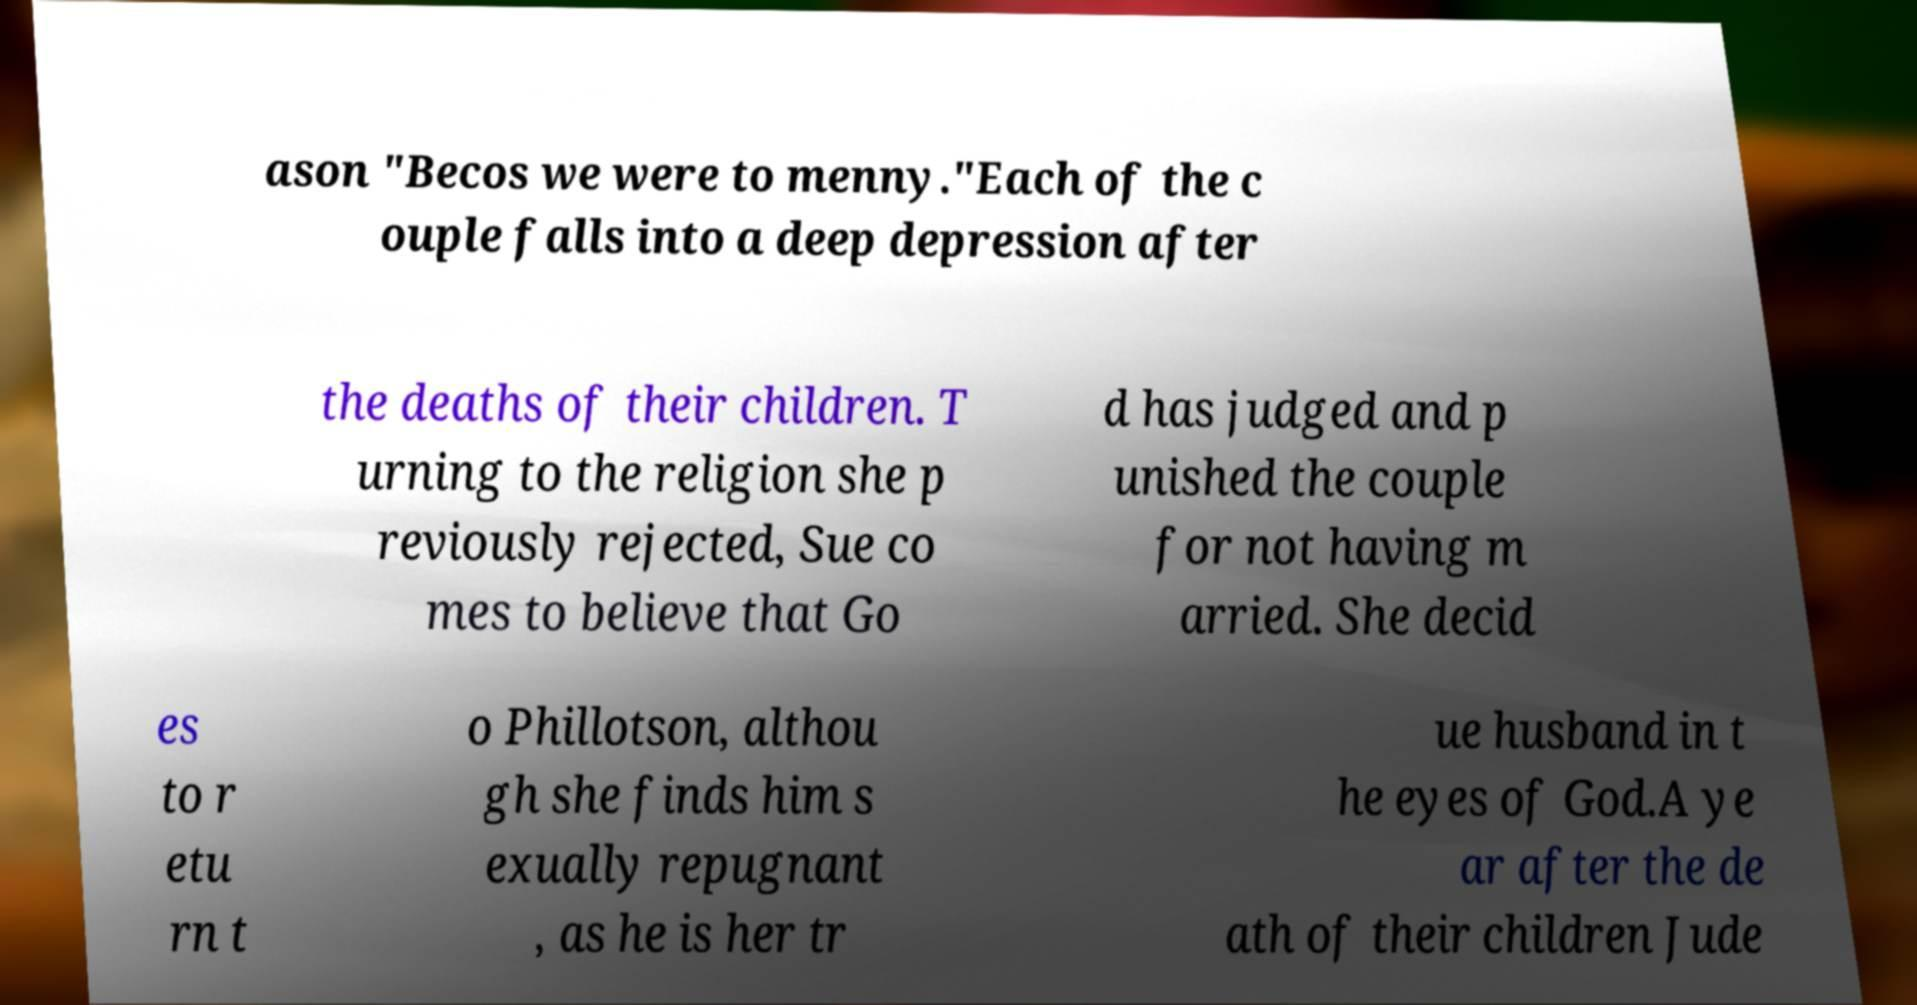Could you assist in decoding the text presented in this image and type it out clearly? ason "Becos we were to menny."Each of the c ouple falls into a deep depression after the deaths of their children. T urning to the religion she p reviously rejected, Sue co mes to believe that Go d has judged and p unished the couple for not having m arried. She decid es to r etu rn t o Phillotson, althou gh she finds him s exually repugnant , as he is her tr ue husband in t he eyes of God.A ye ar after the de ath of their children Jude 